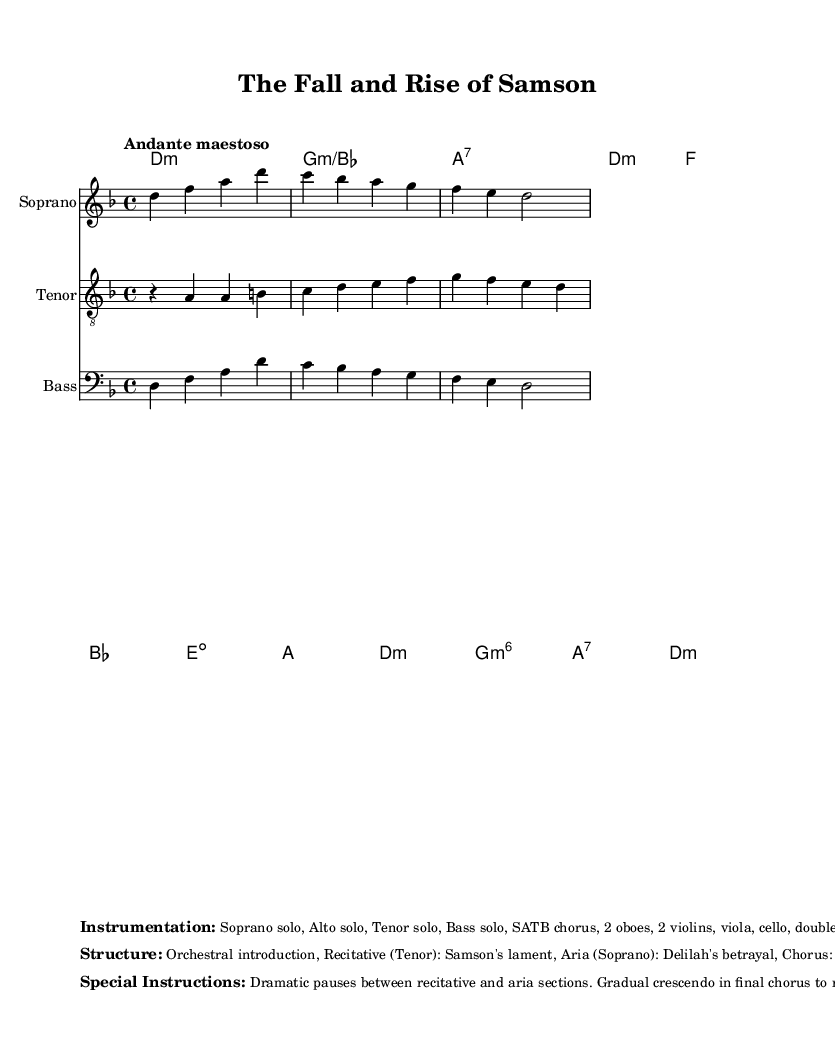What is the key signature of this music? The key signature is indicated at the beginning of the score with two flats, which means it's in D minor since D minor has one flat.
Answer: D minor What is the time signature of this piece? The time signature is shown at the beginning of the score, where it indicates four beats in a measure, represented by the "4/4."
Answer: 4/4 What is the tempo marking for this composition? The tempo is indicated in the score with the phrase "Andante maestoso,” suggesting a moderately slow and majestic pace.
Answer: Andante maestoso How many sections are in the structure of this oratorio? By analyzing the listed structure in the score, we see that it has five distinct sections: orchestral introduction, recitative, aria, and two choruses.
Answer: Five What instruments are included in the instrumentation? The instrumentation is listed in the markup and includes soprano, alto, tenor, bass, SATB chorus, oboes, violins, viola, cello, double bass, and harpsichord.
Answer: Soprano, Alto, Tenor, Bass, SATB chorus, 2 oboes, 2 violins, viola, cello, double bass, harpsichord What type of voice performs the aria "Delilah's betrayal"? The markup specifies that the aria "Delilah's betrayal" is performed by the Soprano, which indicates the character and vocal quality required for that section.
Answer: Soprano What does the crescendo in the final chorus represent? The special instructions state that the gradual crescendo in the final chorus symbolizes the growing redemption theme in the oratorio, highlighting the intense emotional arc.
Answer: Growing redemption 